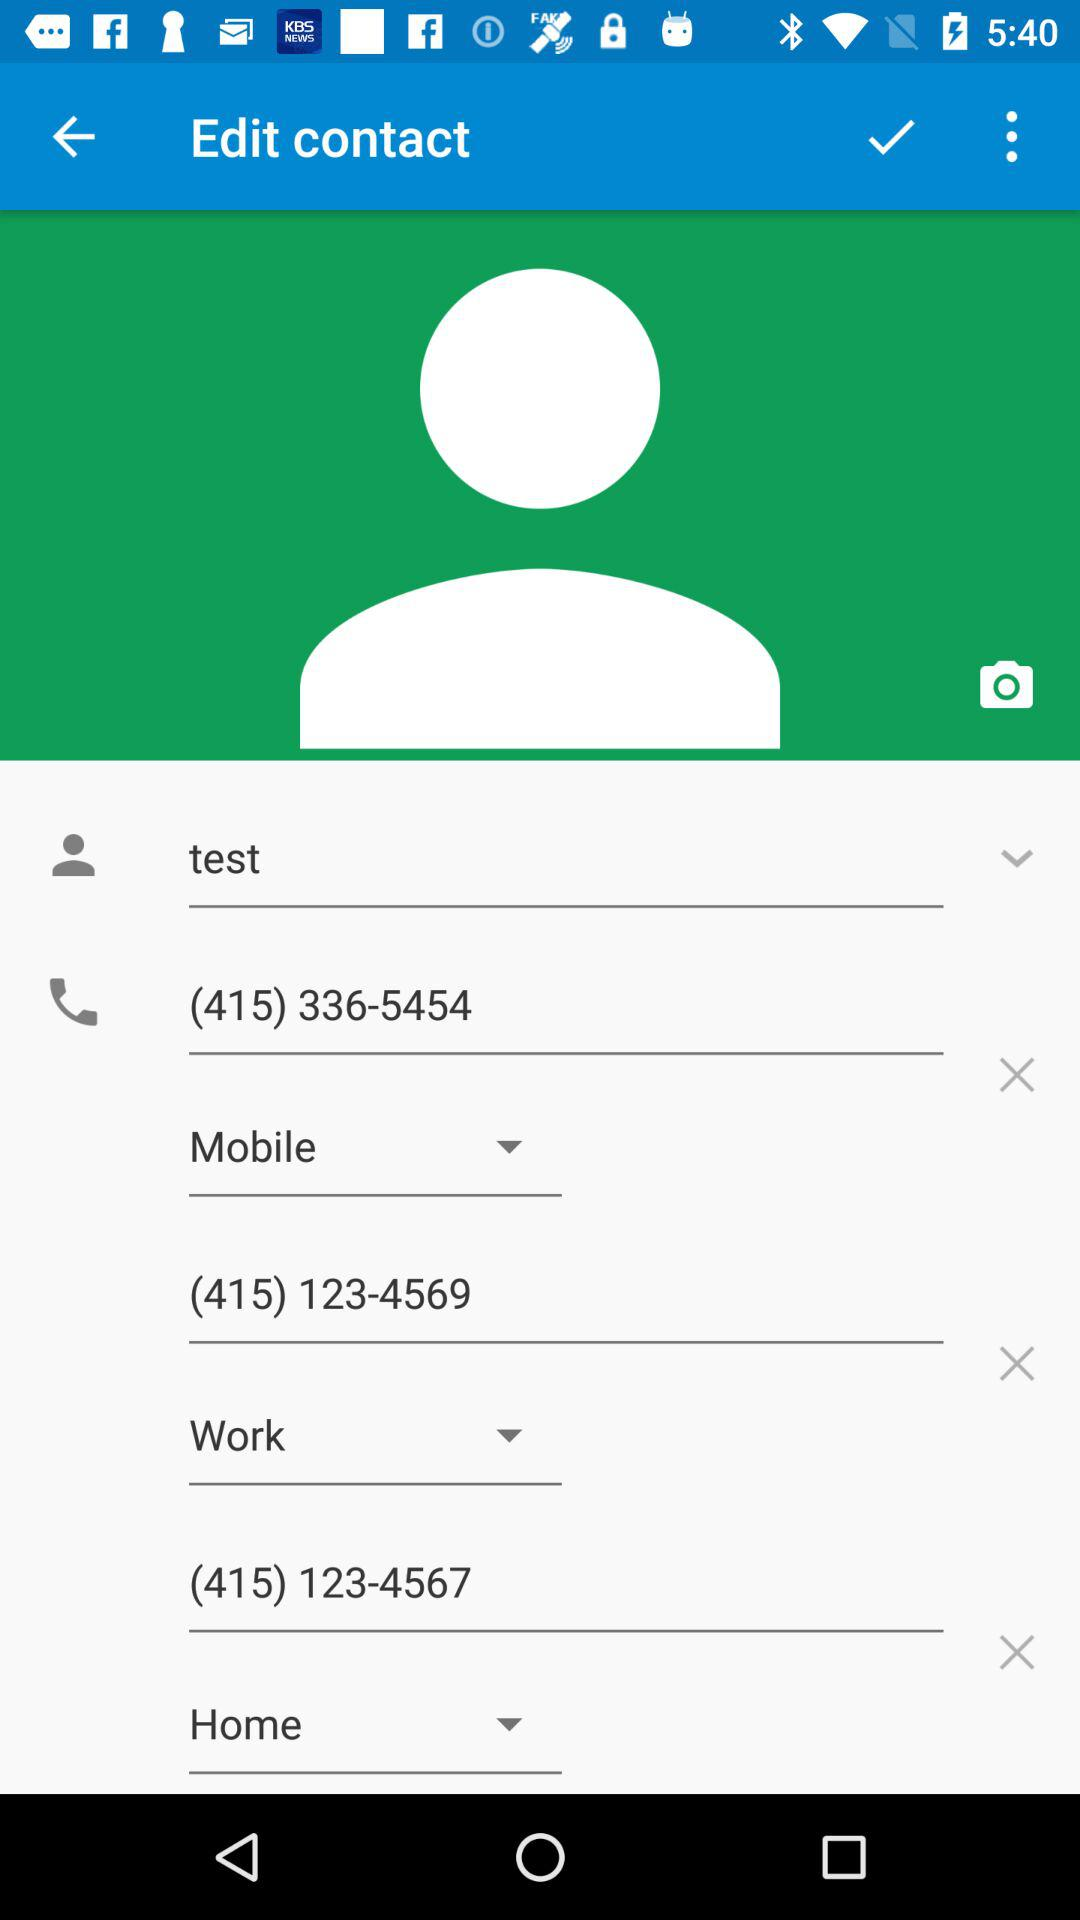How many phone numbers does this contact have?
Answer the question using a single word or phrase. 3 